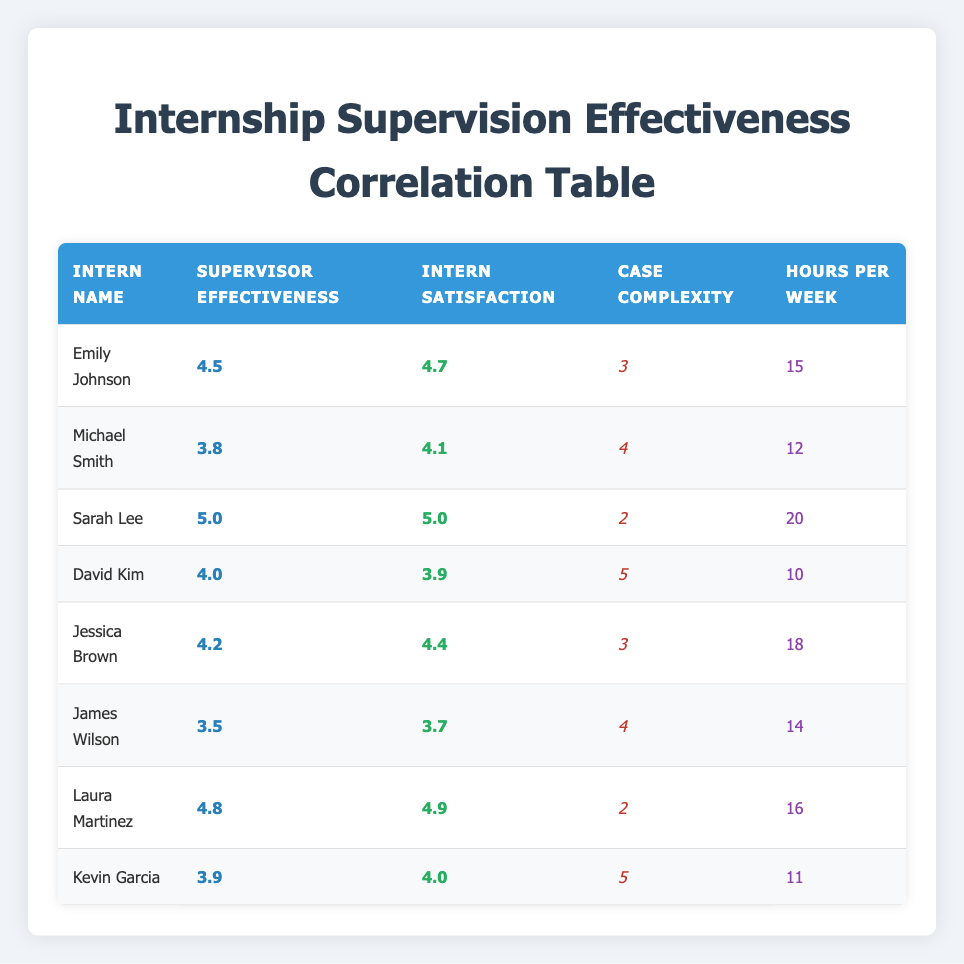What is the supervisor effectiveness score for Sarah Lee? In the table, the row for Sarah Lee lists her supervisor effectiveness score next to her name. It shows a value of 5.0, which indicates her supervisor was rated very effective.
Answer: 5.0 What is the intern satisfaction score for Jessica Brown? The table shows the row for Jessica Brown, where her intern satisfaction score is directly listed alongside her name. The score is 4.4.
Answer: 4.4 Is the statement "Laura Martinez has a higher intern satisfaction score than Emily Johnson" true? To verify this, we check Laura Martinez's intern satisfaction score, which is 4.9, and Emily Johnson's score, which is 4.7. Since 4.9 is greater than 4.7, the statement is true.
Answer: Yes What is the average supervisor effectiveness score of all interns? To calculate the average, we sum all the supervisor effectiveness scores: 4.5 + 3.8 + 5.0 + 4.0 + 4.2 + 3.5 + 4.8 + 3.9 = 34.7. There are 8 interns, so we divide the total by 8: 34.7 / 8 = 4.3375, which rounds to approximately 4.34.
Answer: 4.34 Which intern worked the least hours per week? By examining the hours per week listed for each intern, we find that David Kim worked the least, with a total of 10 hours compared to others.
Answer: David Kim How many interns reported an intern satisfaction score of 4.5 or higher? We review the intern satisfaction scores and identify the following scores greater than or equal to 4.5: Emily Johnson (4.7), Sarah Lee (5.0), Jessica Brown (4.4), Laura Martinez (4.9). Counting these gives us 5 interns with 4.5 or higher satisfaction.
Answer: 5 What is the difference in supervisor effectiveness between Michael Smith and Kevin Garcia? We note that Michael Smith's supervisor effectiveness is 3.8 and Kevin Garcia's is 3.9. The difference between Kevin Garcia's and Michael Smith's scores is calculated as 3.9 - 3.8 = 0.1.
Answer: 0.1 Are there any interns with a supervisor effectiveness score of 5.0? Checking through the table, we find that Sarah Lee is the only intern with a supervisor effectiveness score of 5.0. Therefore, the answer is yes, as there is at least one instance.
Answer: Yes 